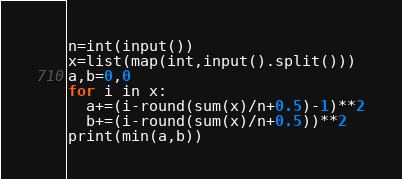Convert code to text. <code><loc_0><loc_0><loc_500><loc_500><_Python_>n=int(input())
x=list(map(int,input().split()))
a,b=0,0
for i in x:
  a+=(i-round(sum(x)/n+0.5)-1)**2
  b+=(i-round(sum(x)/n+0.5))**2
print(min(a,b))</code> 